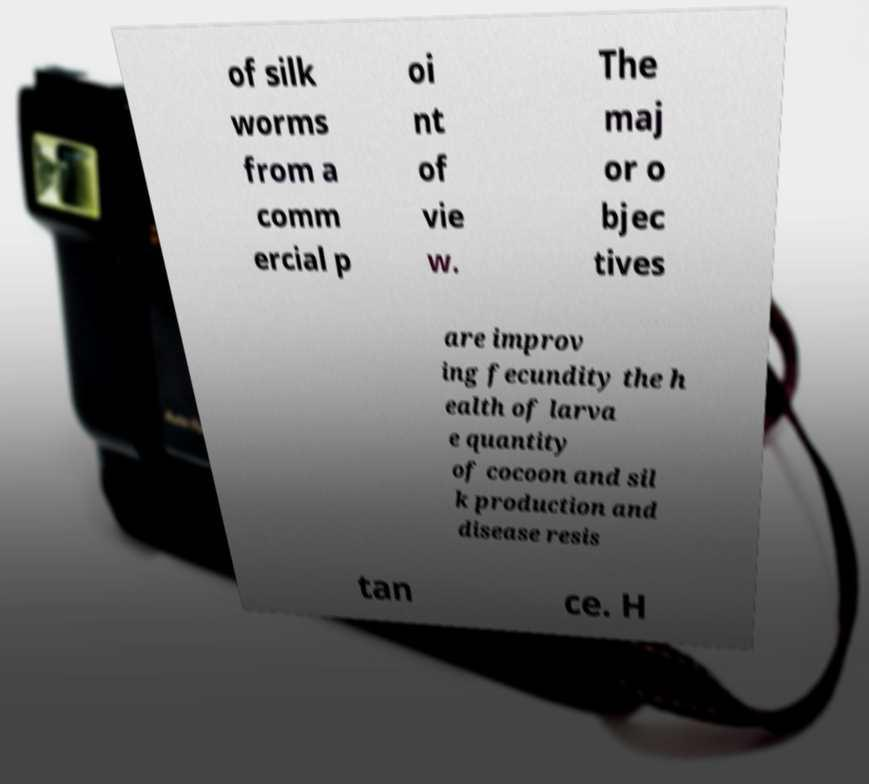Can you read and provide the text displayed in the image?This photo seems to have some interesting text. Can you extract and type it out for me? of silk worms from a comm ercial p oi nt of vie w. The maj or o bjec tives are improv ing fecundity the h ealth of larva e quantity of cocoon and sil k production and disease resis tan ce. H 